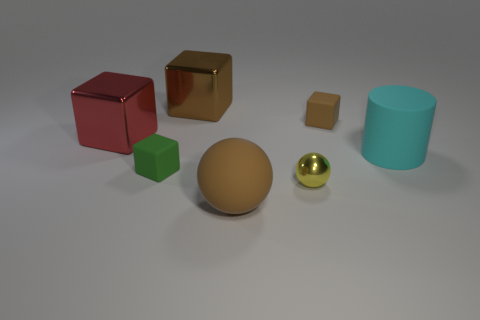How many shiny spheres are there?
Ensure brevity in your answer.  1. There is a brown thing that is in front of the brown thing to the right of the large brown thing in front of the big cyan thing; what is its material?
Your answer should be compact. Rubber. What number of large matte cylinders are left of the big brown object that is in front of the metallic ball?
Keep it short and to the point. 0. What is the color of the other small matte object that is the same shape as the small green rubber object?
Offer a terse response. Brown. Is the small yellow thing made of the same material as the brown ball?
Make the answer very short. No. How many blocks are cyan objects or tiny green things?
Offer a terse response. 1. There is a brown object that is in front of the tiny block that is in front of the large object right of the yellow sphere; how big is it?
Provide a short and direct response. Large. What is the size of the brown metal thing that is the same shape as the green thing?
Offer a terse response. Large. There is a cylinder; what number of small matte objects are on the right side of it?
Provide a succinct answer. 0. There is a small block on the right side of the big brown metal thing; does it have the same color as the large sphere?
Provide a short and direct response. Yes. 